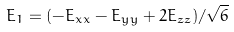<formula> <loc_0><loc_0><loc_500><loc_500>E _ { 1 } = ( - E _ { x x } - E _ { y y } + 2 E _ { z z } ) / { \sqrt { 6 } }</formula> 